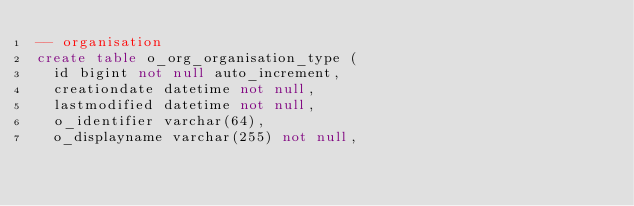Convert code to text. <code><loc_0><loc_0><loc_500><loc_500><_SQL_>-- organisation
create table o_org_organisation_type (
  id bigint not null auto_increment,
  creationdate datetime not null,
  lastmodified datetime not null,
  o_identifier varchar(64),
  o_displayname varchar(255) not null,</code> 